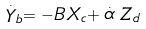Convert formula to latex. <formula><loc_0><loc_0><loc_500><loc_500>\stackrel { . } { Y } _ { b } = - B X _ { c } + \stackrel { . } { \alpha } Z _ { d }</formula> 